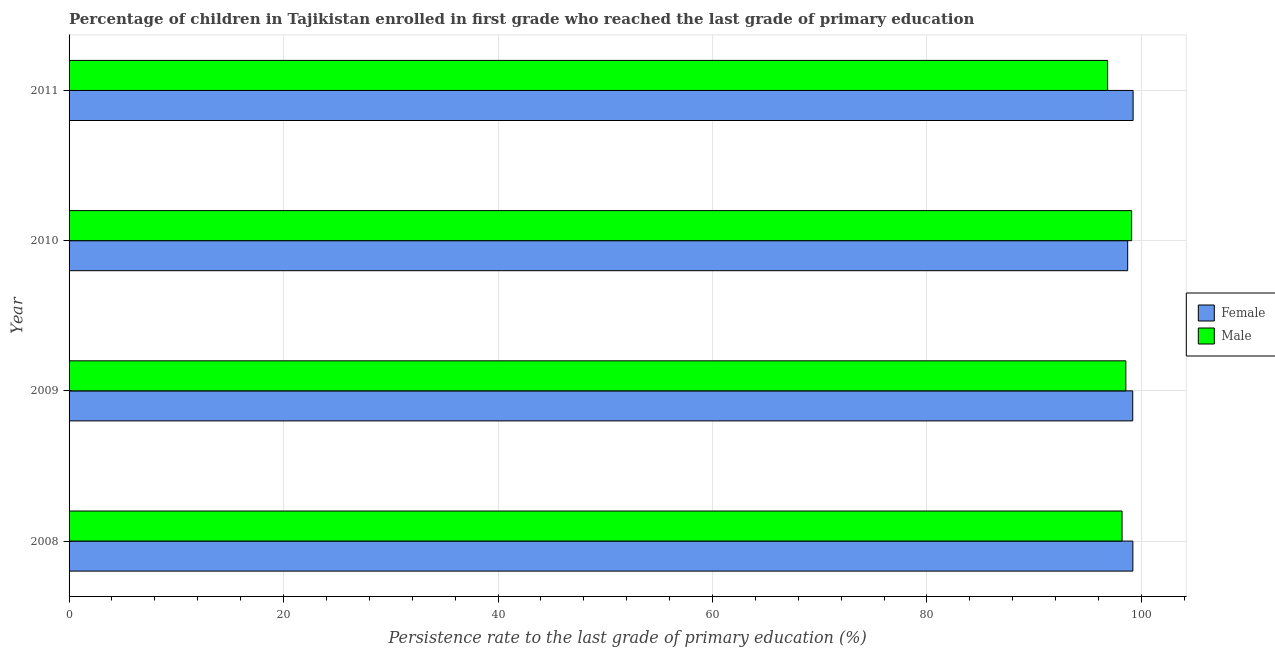How many groups of bars are there?
Offer a terse response. 4. Are the number of bars per tick equal to the number of legend labels?
Offer a terse response. Yes. Are the number of bars on each tick of the Y-axis equal?
Your answer should be very brief. Yes. How many bars are there on the 2nd tick from the top?
Keep it short and to the point. 2. What is the label of the 1st group of bars from the top?
Keep it short and to the point. 2011. In how many cases, is the number of bars for a given year not equal to the number of legend labels?
Keep it short and to the point. 0. What is the persistence rate of male students in 2011?
Give a very brief answer. 96.85. Across all years, what is the maximum persistence rate of male students?
Your response must be concise. 99.09. Across all years, what is the minimum persistence rate of male students?
Make the answer very short. 96.85. In which year was the persistence rate of male students maximum?
Ensure brevity in your answer.  2010. What is the total persistence rate of male students in the graph?
Make the answer very short. 392.7. What is the difference between the persistence rate of female students in 2009 and that in 2010?
Keep it short and to the point. 0.47. What is the difference between the persistence rate of female students in 2009 and the persistence rate of male students in 2011?
Provide a short and direct response. 2.34. What is the average persistence rate of female students per year?
Your answer should be compact. 99.09. In the year 2011, what is the difference between the persistence rate of female students and persistence rate of male students?
Make the answer very short. 2.37. Is the persistence rate of male students in 2008 less than that in 2010?
Your response must be concise. Yes. Is the difference between the persistence rate of male students in 2009 and 2010 greater than the difference between the persistence rate of female students in 2009 and 2010?
Provide a short and direct response. No. What is the difference between the highest and the second highest persistence rate of male students?
Give a very brief answer. 0.54. In how many years, is the persistence rate of male students greater than the average persistence rate of male students taken over all years?
Ensure brevity in your answer.  3. Is the sum of the persistence rate of female students in 2008 and 2010 greater than the maximum persistence rate of male students across all years?
Provide a short and direct response. Yes. What does the 1st bar from the top in 2010 represents?
Make the answer very short. Male. What does the 2nd bar from the bottom in 2011 represents?
Your response must be concise. Male. Are all the bars in the graph horizontal?
Ensure brevity in your answer.  Yes. What is the difference between two consecutive major ticks on the X-axis?
Offer a very short reply. 20. Are the values on the major ticks of X-axis written in scientific E-notation?
Make the answer very short. No. Where does the legend appear in the graph?
Your response must be concise. Center right. How many legend labels are there?
Offer a terse response. 2. How are the legend labels stacked?
Keep it short and to the point. Vertical. What is the title of the graph?
Keep it short and to the point. Percentage of children in Tajikistan enrolled in first grade who reached the last grade of primary education. What is the label or title of the X-axis?
Provide a short and direct response. Persistence rate to the last grade of primary education (%). What is the Persistence rate to the last grade of primary education (%) in Female in 2008?
Your answer should be very brief. 99.21. What is the Persistence rate to the last grade of primary education (%) of Male in 2008?
Keep it short and to the point. 98.2. What is the Persistence rate to the last grade of primary education (%) in Female in 2009?
Provide a succinct answer. 99.19. What is the Persistence rate to the last grade of primary education (%) in Male in 2009?
Provide a short and direct response. 98.55. What is the Persistence rate to the last grade of primary education (%) in Female in 2010?
Your answer should be compact. 98.72. What is the Persistence rate to the last grade of primary education (%) of Male in 2010?
Keep it short and to the point. 99.09. What is the Persistence rate to the last grade of primary education (%) in Female in 2011?
Offer a terse response. 99.23. What is the Persistence rate to the last grade of primary education (%) in Male in 2011?
Keep it short and to the point. 96.85. Across all years, what is the maximum Persistence rate to the last grade of primary education (%) of Female?
Keep it short and to the point. 99.23. Across all years, what is the maximum Persistence rate to the last grade of primary education (%) of Male?
Your answer should be compact. 99.09. Across all years, what is the minimum Persistence rate to the last grade of primary education (%) in Female?
Ensure brevity in your answer.  98.72. Across all years, what is the minimum Persistence rate to the last grade of primary education (%) of Male?
Provide a short and direct response. 96.85. What is the total Persistence rate to the last grade of primary education (%) in Female in the graph?
Make the answer very short. 396.35. What is the total Persistence rate to the last grade of primary education (%) in Male in the graph?
Your response must be concise. 392.7. What is the difference between the Persistence rate to the last grade of primary education (%) in Female in 2008 and that in 2009?
Offer a terse response. 0.01. What is the difference between the Persistence rate to the last grade of primary education (%) of Male in 2008 and that in 2009?
Your answer should be compact. -0.35. What is the difference between the Persistence rate to the last grade of primary education (%) in Female in 2008 and that in 2010?
Your answer should be compact. 0.48. What is the difference between the Persistence rate to the last grade of primary education (%) in Male in 2008 and that in 2010?
Your answer should be compact. -0.89. What is the difference between the Persistence rate to the last grade of primary education (%) in Female in 2008 and that in 2011?
Keep it short and to the point. -0.02. What is the difference between the Persistence rate to the last grade of primary education (%) of Male in 2008 and that in 2011?
Offer a very short reply. 1.34. What is the difference between the Persistence rate to the last grade of primary education (%) in Female in 2009 and that in 2010?
Keep it short and to the point. 0.47. What is the difference between the Persistence rate to the last grade of primary education (%) of Male in 2009 and that in 2010?
Offer a terse response. -0.54. What is the difference between the Persistence rate to the last grade of primary education (%) of Female in 2009 and that in 2011?
Offer a very short reply. -0.03. What is the difference between the Persistence rate to the last grade of primary education (%) in Male in 2009 and that in 2011?
Provide a succinct answer. 1.7. What is the difference between the Persistence rate to the last grade of primary education (%) of Female in 2010 and that in 2011?
Your answer should be very brief. -0.5. What is the difference between the Persistence rate to the last grade of primary education (%) in Male in 2010 and that in 2011?
Keep it short and to the point. 2.24. What is the difference between the Persistence rate to the last grade of primary education (%) in Female in 2008 and the Persistence rate to the last grade of primary education (%) in Male in 2009?
Offer a terse response. 0.66. What is the difference between the Persistence rate to the last grade of primary education (%) of Female in 2008 and the Persistence rate to the last grade of primary education (%) of Male in 2010?
Keep it short and to the point. 0.11. What is the difference between the Persistence rate to the last grade of primary education (%) of Female in 2008 and the Persistence rate to the last grade of primary education (%) of Male in 2011?
Your response must be concise. 2.35. What is the difference between the Persistence rate to the last grade of primary education (%) in Female in 2009 and the Persistence rate to the last grade of primary education (%) in Male in 2010?
Ensure brevity in your answer.  0.1. What is the difference between the Persistence rate to the last grade of primary education (%) in Female in 2009 and the Persistence rate to the last grade of primary education (%) in Male in 2011?
Ensure brevity in your answer.  2.34. What is the difference between the Persistence rate to the last grade of primary education (%) of Female in 2010 and the Persistence rate to the last grade of primary education (%) of Male in 2011?
Your answer should be compact. 1.87. What is the average Persistence rate to the last grade of primary education (%) in Female per year?
Offer a terse response. 99.09. What is the average Persistence rate to the last grade of primary education (%) of Male per year?
Provide a succinct answer. 98.17. In the year 2008, what is the difference between the Persistence rate to the last grade of primary education (%) of Female and Persistence rate to the last grade of primary education (%) of Male?
Offer a very short reply. 1.01. In the year 2009, what is the difference between the Persistence rate to the last grade of primary education (%) in Female and Persistence rate to the last grade of primary education (%) in Male?
Offer a terse response. 0.64. In the year 2010, what is the difference between the Persistence rate to the last grade of primary education (%) in Female and Persistence rate to the last grade of primary education (%) in Male?
Make the answer very short. -0.37. In the year 2011, what is the difference between the Persistence rate to the last grade of primary education (%) of Female and Persistence rate to the last grade of primary education (%) of Male?
Offer a very short reply. 2.37. What is the ratio of the Persistence rate to the last grade of primary education (%) in Female in 2008 to that in 2009?
Provide a succinct answer. 1. What is the ratio of the Persistence rate to the last grade of primary education (%) of Male in 2008 to that in 2010?
Keep it short and to the point. 0.99. What is the ratio of the Persistence rate to the last grade of primary education (%) in Male in 2008 to that in 2011?
Provide a short and direct response. 1.01. What is the ratio of the Persistence rate to the last grade of primary education (%) in Female in 2009 to that in 2010?
Make the answer very short. 1. What is the ratio of the Persistence rate to the last grade of primary education (%) of Male in 2009 to that in 2010?
Ensure brevity in your answer.  0.99. What is the ratio of the Persistence rate to the last grade of primary education (%) in Female in 2009 to that in 2011?
Provide a succinct answer. 1. What is the ratio of the Persistence rate to the last grade of primary education (%) of Male in 2009 to that in 2011?
Provide a succinct answer. 1.02. What is the ratio of the Persistence rate to the last grade of primary education (%) in Male in 2010 to that in 2011?
Ensure brevity in your answer.  1.02. What is the difference between the highest and the second highest Persistence rate to the last grade of primary education (%) in Female?
Your response must be concise. 0.02. What is the difference between the highest and the second highest Persistence rate to the last grade of primary education (%) of Male?
Ensure brevity in your answer.  0.54. What is the difference between the highest and the lowest Persistence rate to the last grade of primary education (%) of Female?
Give a very brief answer. 0.5. What is the difference between the highest and the lowest Persistence rate to the last grade of primary education (%) in Male?
Offer a terse response. 2.24. 